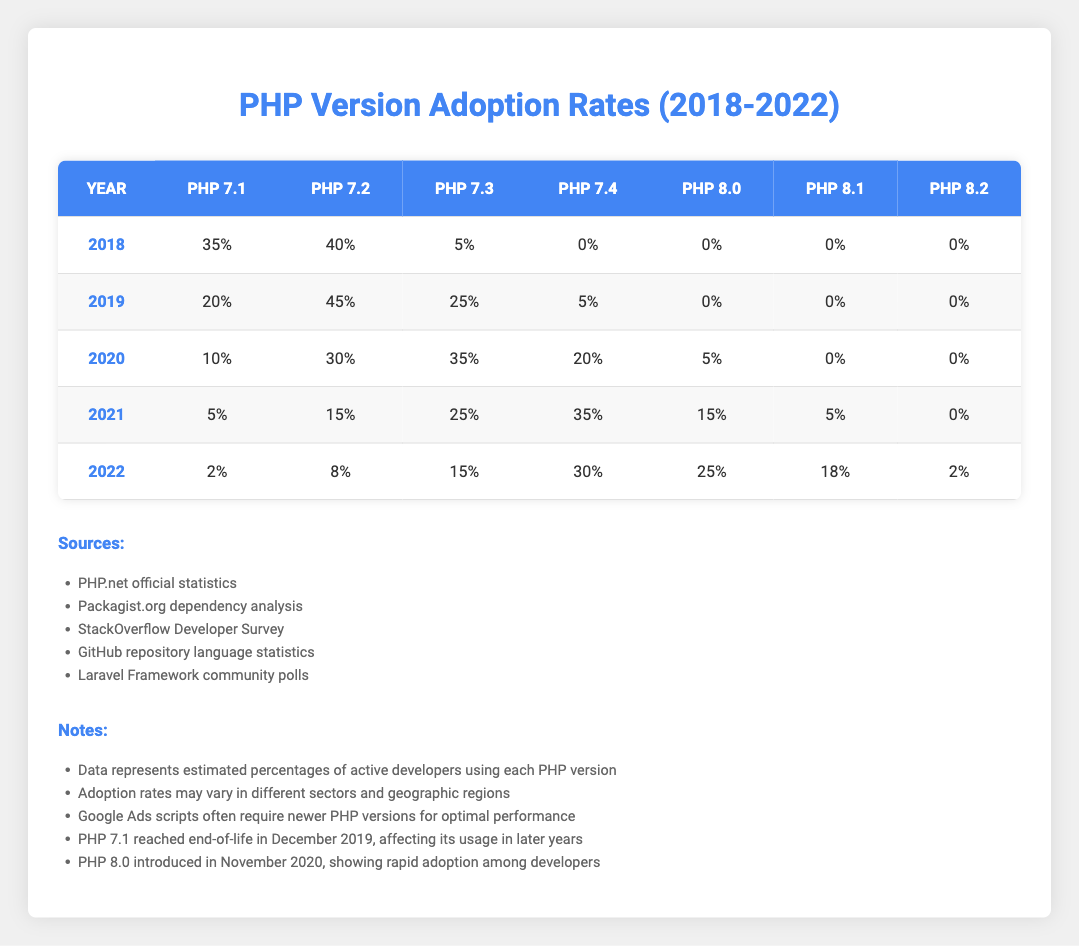What was the adoption rate of PHP 7.4 in 2021? In the year 2021, the adoption rate for PHP 7.4 is shown in the table, specifically in that row under the "PHP 7.4" column. It indicates a rate of 35%.
Answer: 35% Which version had the highest adoption rate in 2019? Referring to the 2019 row, the "PHP 7.2" column shows the highest number at 45%, which is greater than the other versions listed for that year.
Answer: PHP 7.2 What was the average adoption rate of PHP 8.0 across the years displayed? To find the average, sum the adoption rates for PHP 8.0 across all years: (0 + 0 + 5 + 15 + 25) = 45. Then divide by the number of years (5), which results in 45/5 = 9.
Answer: 9% Is it true that PHP 7.1 had any adoption rate in 2022? Checking the 2022 row under the "PHP 7.1" column shows a rate of 2%, which confirms that it did have an adoption rate that year.
Answer: Yes What is the difference in adoption rates of PHP 7.3 between 2018 and 2022? The adoption rate for PHP 7.3 in 2018 is 5%, and in 2022 it is 15%. To find the difference, subtract the 2018 rate from the 2022 rate: 15% - 5% = 10%.
Answer: 10% Which PHP version saw the greatest increase in adoption from 2020 to 2021? Looking at the rates, PHP 7.4 had an increase from 20% in 2020 to 35% in 2021, which is a rise of 15%. PHP 8.0 also increased from 5% to 15%, a rise of 10%. The greatest increase is thus for PHP 7.4.
Answer: PHP 7.4 What percentage of developers used PHP 8.1 in 2022? The table shows that in 2022, the adoption rate for PHP 8.1 is 18%, found in that specific row under the "PHP 8.1" column.
Answer: 18% In 2020, what version had the lowest adoption rate? The adoption rates for 2020 for all versions must be compared: PHP 7.1 (10%), 7.2 (30%), 7.3 (35%), 7.4 (20%), PHP 8.0 (5%). The lowest is from PHP 8.0.
Answer: PHP 8.0 